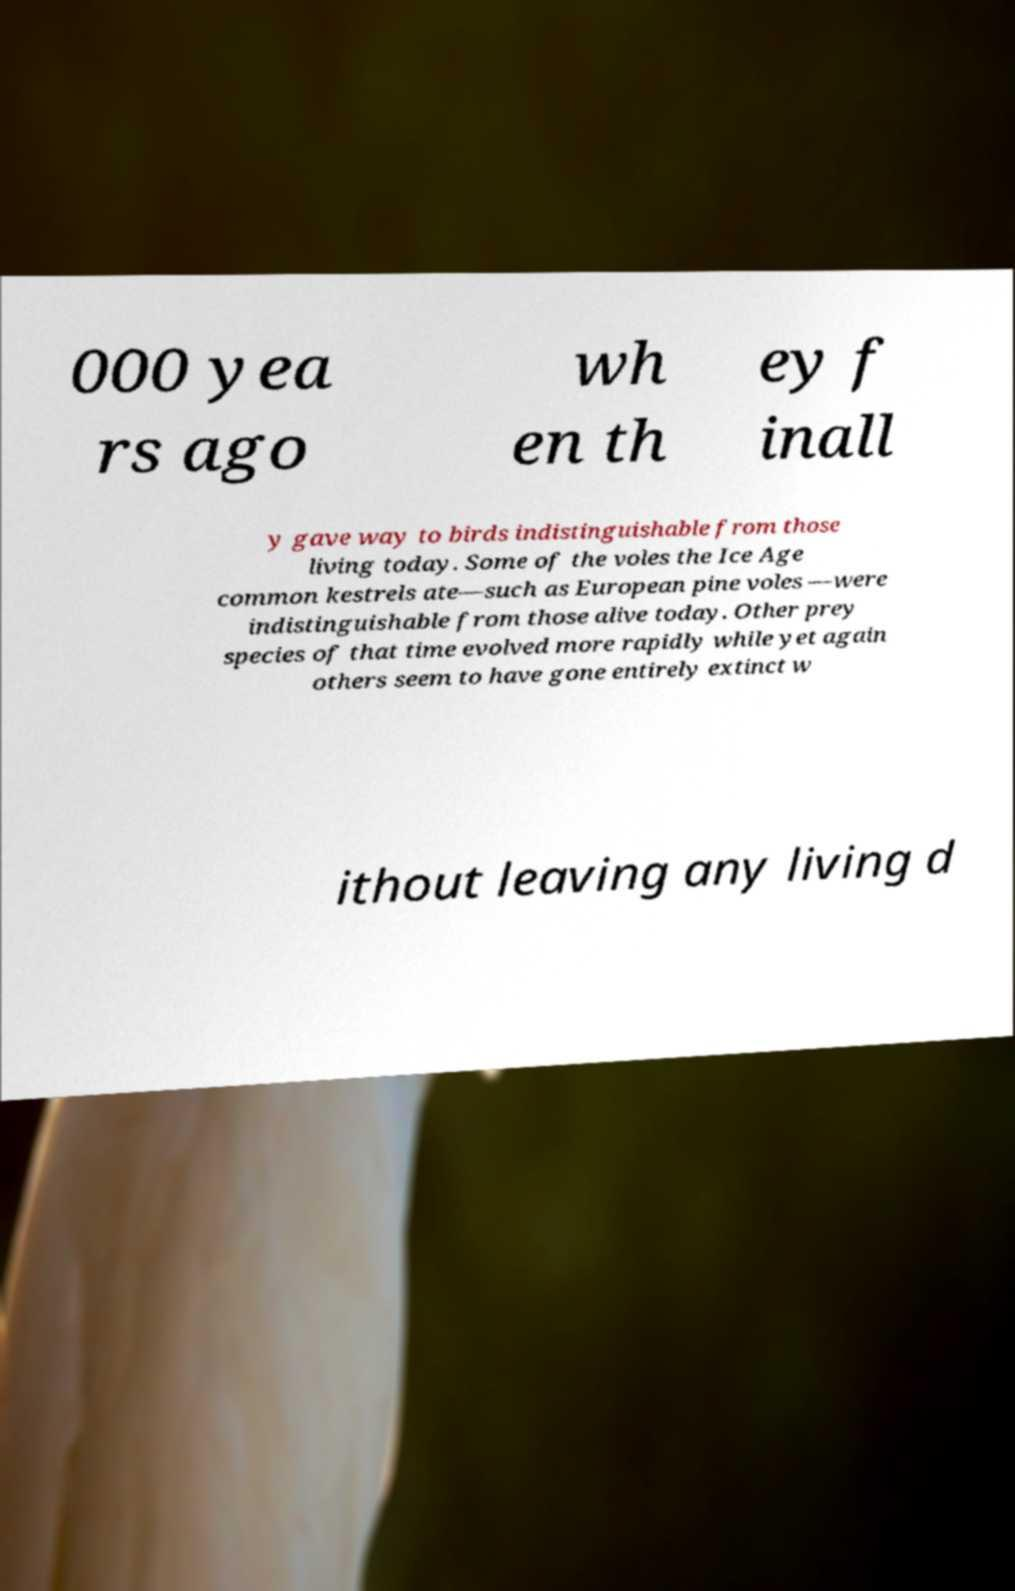Can you accurately transcribe the text from the provided image for me? 000 yea rs ago wh en th ey f inall y gave way to birds indistinguishable from those living today. Some of the voles the Ice Age common kestrels ate—such as European pine voles —were indistinguishable from those alive today. Other prey species of that time evolved more rapidly while yet again others seem to have gone entirely extinct w ithout leaving any living d 